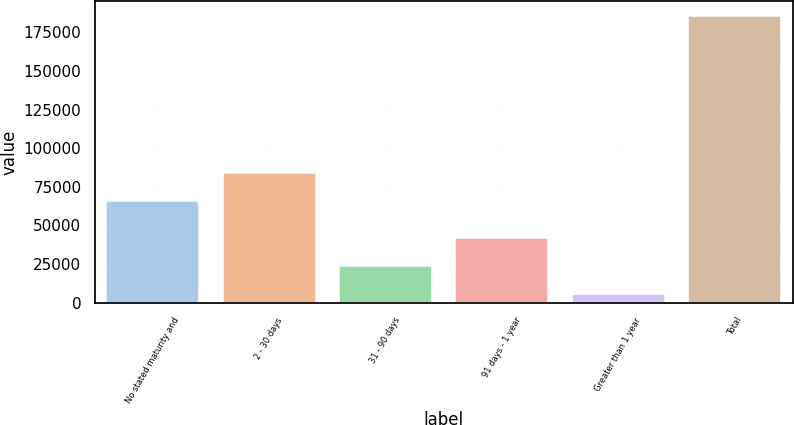Convert chart to OTSL. <chart><loc_0><loc_0><loc_500><loc_500><bar_chart><fcel>No stated maturity and<fcel>2 - 30 days<fcel>31 - 90 days<fcel>91 days - 1 year<fcel>Greater than 1 year<fcel>Total<nl><fcel>65764<fcel>83765.9<fcel>23731.9<fcel>41733.8<fcel>5730<fcel>185749<nl></chart> 